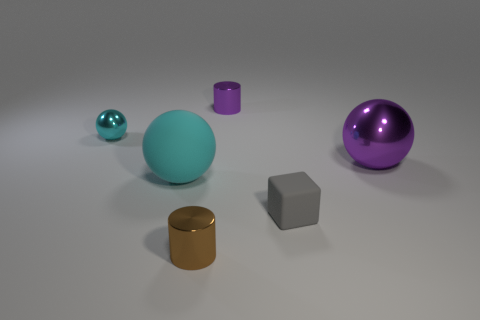Add 2 gray rubber objects. How many objects exist? 8 Subtract all cylinders. How many objects are left? 4 Subtract all tiny cubes. Subtract all tiny cubes. How many objects are left? 4 Add 3 tiny cyan metal balls. How many tiny cyan metal balls are left? 4 Add 5 tiny objects. How many tiny objects exist? 9 Subtract 0 cyan cubes. How many objects are left? 6 